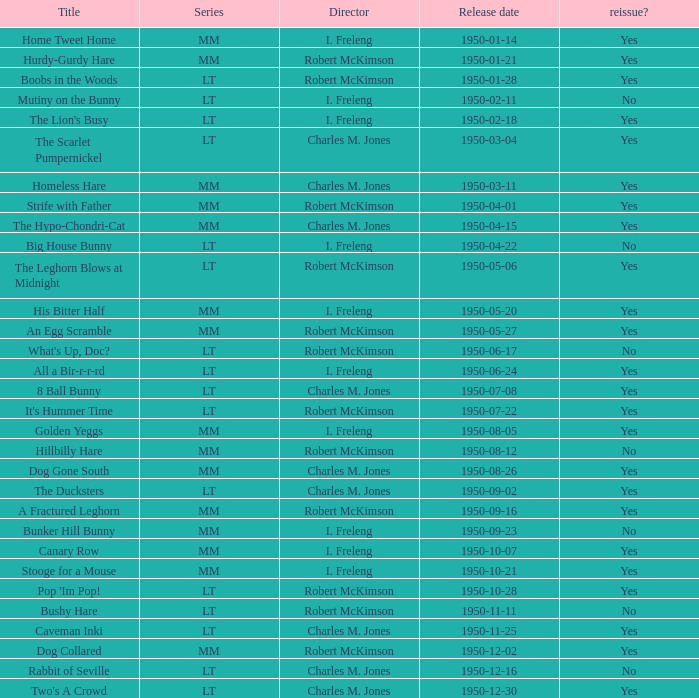Who directed An Egg Scramble? Robert McKimson. 